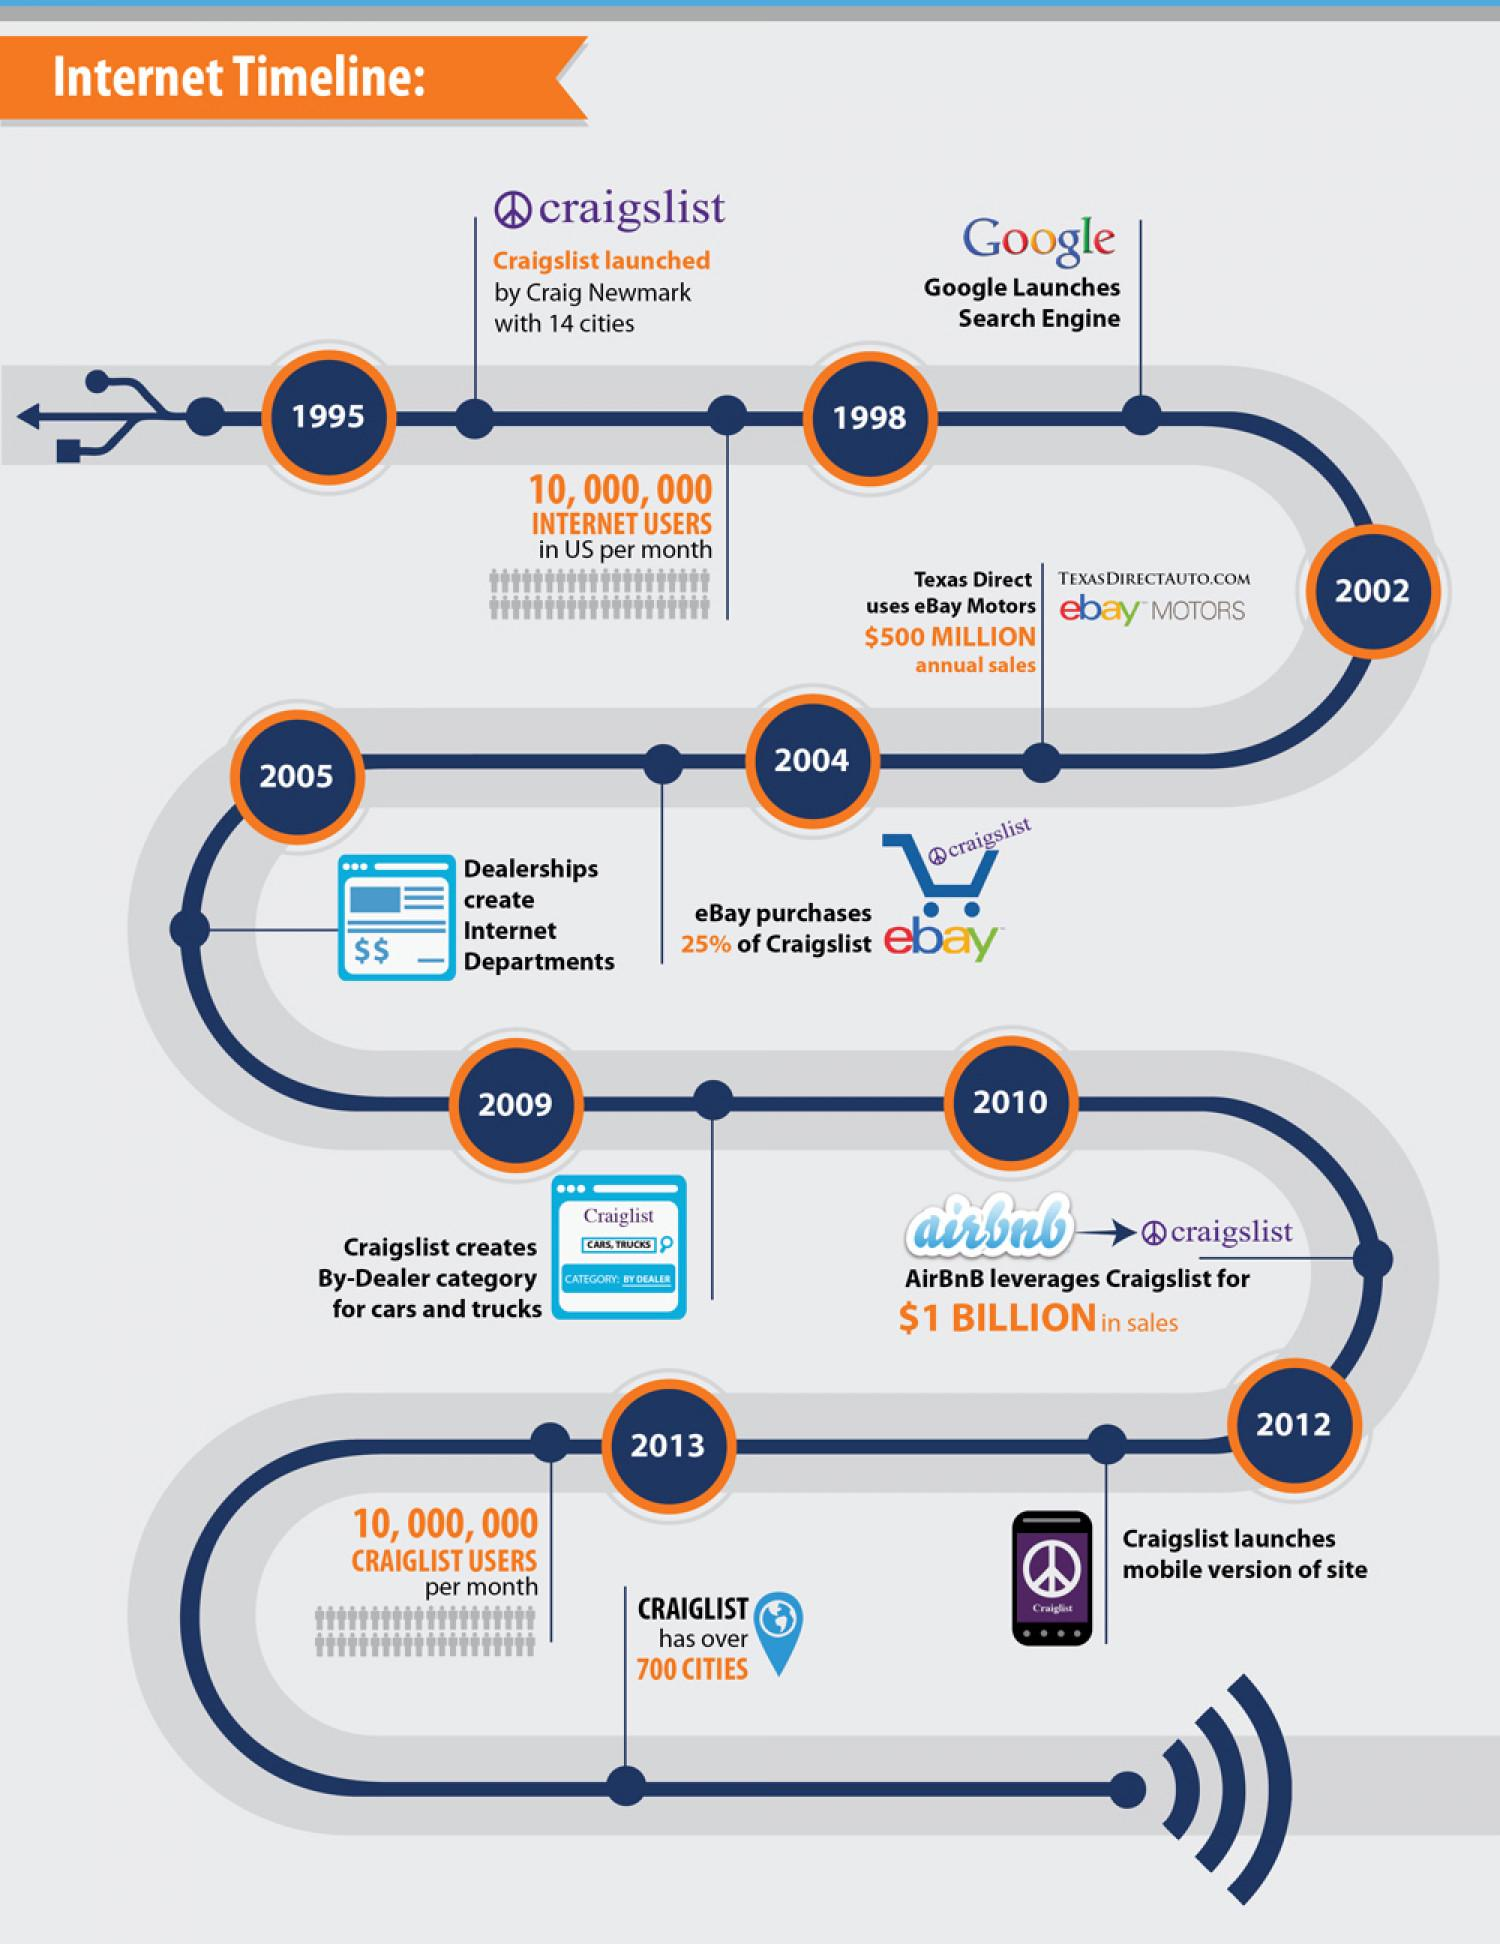Point out several critical features in this image. Before 1998, the number of internet users per month in the US was approximately 10 million. Craig Newmark founded Craigslist. In 2013, the number of Craigslist users per month was approximately 10 million. In the year 1995, Craigslist was launched. It is reported that a seller named Texas Direct on eBay Motors achieved an annual sales revenue of $500 million. 